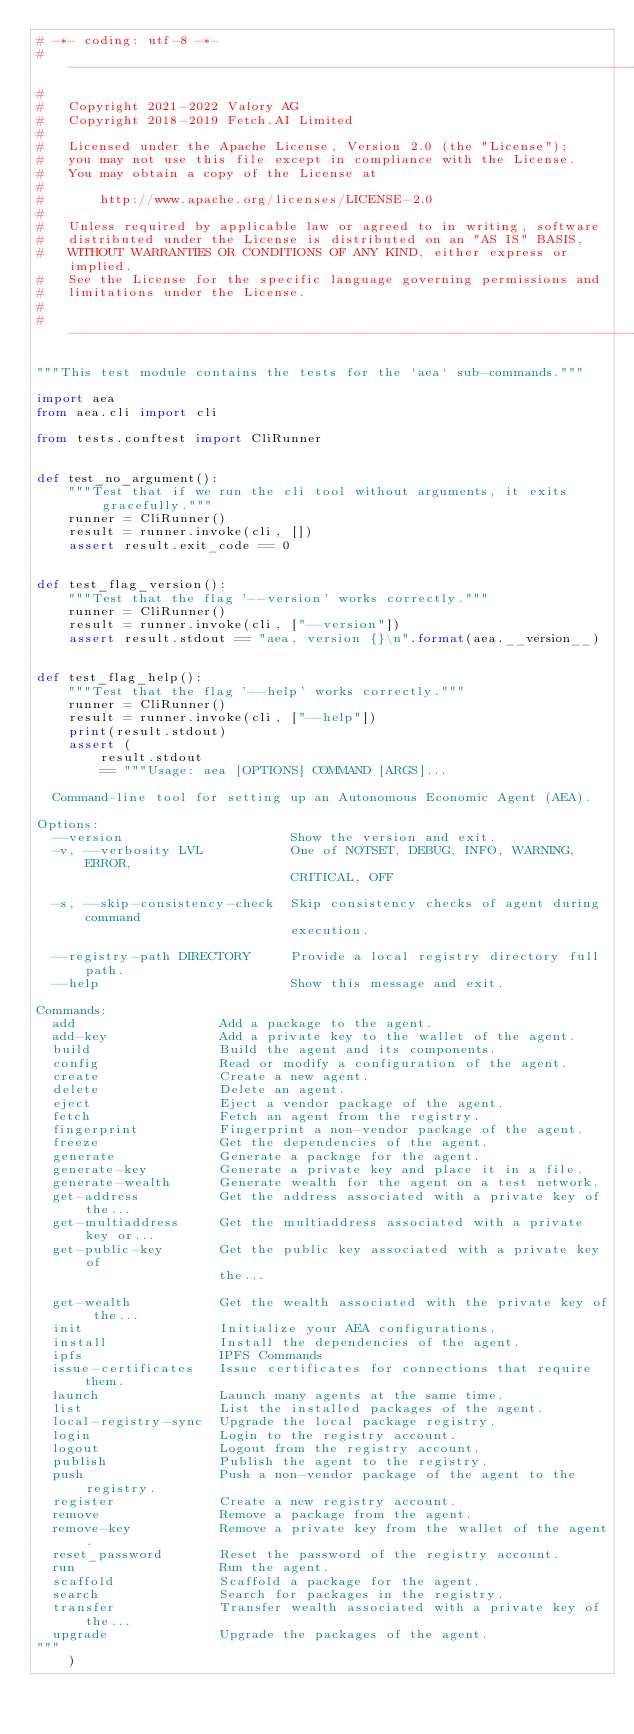Convert code to text. <code><loc_0><loc_0><loc_500><loc_500><_Python_># -*- coding: utf-8 -*-
# ------------------------------------------------------------------------------
#
#   Copyright 2021-2022 Valory AG
#   Copyright 2018-2019 Fetch.AI Limited
#
#   Licensed under the Apache License, Version 2.0 (the "License");
#   you may not use this file except in compliance with the License.
#   You may obtain a copy of the License at
#
#       http://www.apache.org/licenses/LICENSE-2.0
#
#   Unless required by applicable law or agreed to in writing, software
#   distributed under the License is distributed on an "AS IS" BASIS,
#   WITHOUT WARRANTIES OR CONDITIONS OF ANY KIND, either express or implied.
#   See the License for the specific language governing permissions and
#   limitations under the License.
#
# ------------------------------------------------------------------------------

"""This test module contains the tests for the `aea` sub-commands."""

import aea
from aea.cli import cli

from tests.conftest import CliRunner


def test_no_argument():
    """Test that if we run the cli tool without arguments, it exits gracefully."""
    runner = CliRunner()
    result = runner.invoke(cli, [])
    assert result.exit_code == 0


def test_flag_version():
    """Test that the flag '--version' works correctly."""
    runner = CliRunner()
    result = runner.invoke(cli, ["--version"])
    assert result.stdout == "aea, version {}\n".format(aea.__version__)


def test_flag_help():
    """Test that the flag '--help' works correctly."""
    runner = CliRunner()
    result = runner.invoke(cli, ["--help"])
    print(result.stdout)
    assert (
        result.stdout
        == """Usage: aea [OPTIONS] COMMAND [ARGS]...

  Command-line tool for setting up an Autonomous Economic Agent (AEA).

Options:
  --version                     Show the version and exit.
  -v, --verbosity LVL           One of NOTSET, DEBUG, INFO, WARNING, ERROR,
                                CRITICAL, OFF

  -s, --skip-consistency-check  Skip consistency checks of agent during command
                                execution.

  --registry-path DIRECTORY     Provide a local registry directory full path.
  --help                        Show this message and exit.

Commands:
  add                  Add a package to the agent.
  add-key              Add a private key to the wallet of the agent.
  build                Build the agent and its components.
  config               Read or modify a configuration of the agent.
  create               Create a new agent.
  delete               Delete an agent.
  eject                Eject a vendor package of the agent.
  fetch                Fetch an agent from the registry.
  fingerprint          Fingerprint a non-vendor package of the agent.
  freeze               Get the dependencies of the agent.
  generate             Generate a package for the agent.
  generate-key         Generate a private key and place it in a file.
  generate-wealth      Generate wealth for the agent on a test network.
  get-address          Get the address associated with a private key of the...
  get-multiaddress     Get the multiaddress associated with a private key or...
  get-public-key       Get the public key associated with a private key of
                       the...

  get-wealth           Get the wealth associated with the private key of the...
  init                 Initialize your AEA configurations.
  install              Install the dependencies of the agent.
  ipfs                 IPFS Commands
  issue-certificates   Issue certificates for connections that require them.
  launch               Launch many agents at the same time.
  list                 List the installed packages of the agent.
  local-registry-sync  Upgrade the local package registry.
  login                Login to the registry account.
  logout               Logout from the registry account.
  publish              Publish the agent to the registry.
  push                 Push a non-vendor package of the agent to the registry.
  register             Create a new registry account.
  remove               Remove a package from the agent.
  remove-key           Remove a private key from the wallet of the agent.
  reset_password       Reset the password of the registry account.
  run                  Run the agent.
  scaffold             Scaffold a package for the agent.
  search               Search for packages in the registry.
  transfer             Transfer wealth associated with a private key of the...
  upgrade              Upgrade the packages of the agent.
"""
    )
</code> 